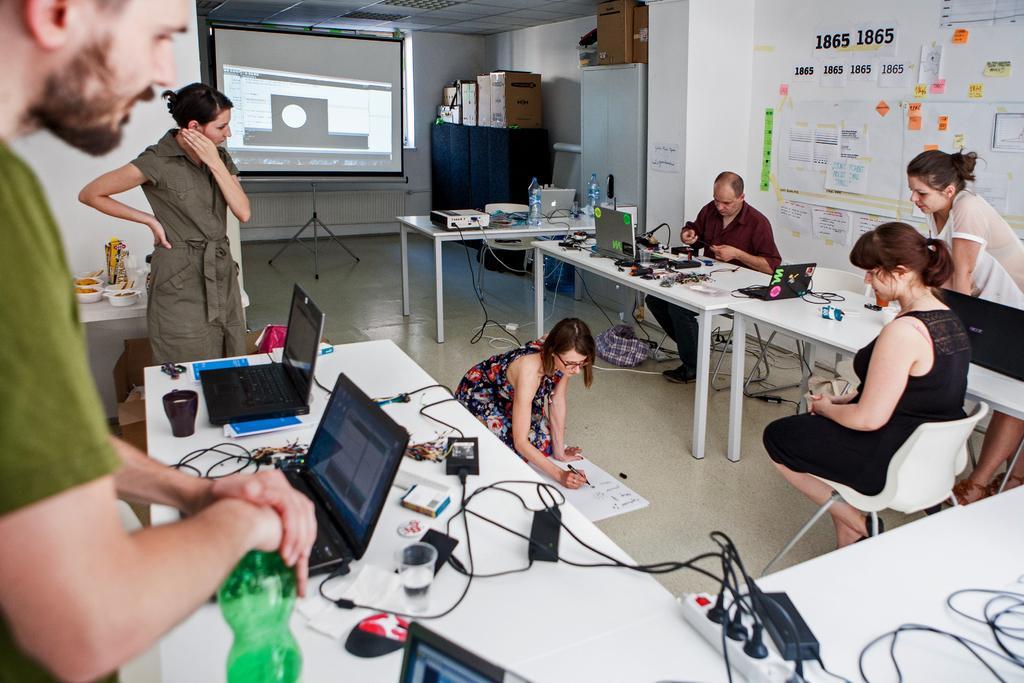Describe this image in one or two sentences. On the left we can see one man standing and holding water bottle. In front there is a table,on table we can see laptop,glass,wire,mouse and paper. In the center there is a woman sitting on the floor and holding pen and the other woman sitting on the chair. In the background there is a board,window,table,pillar,wall,charts and few persons were standing. 